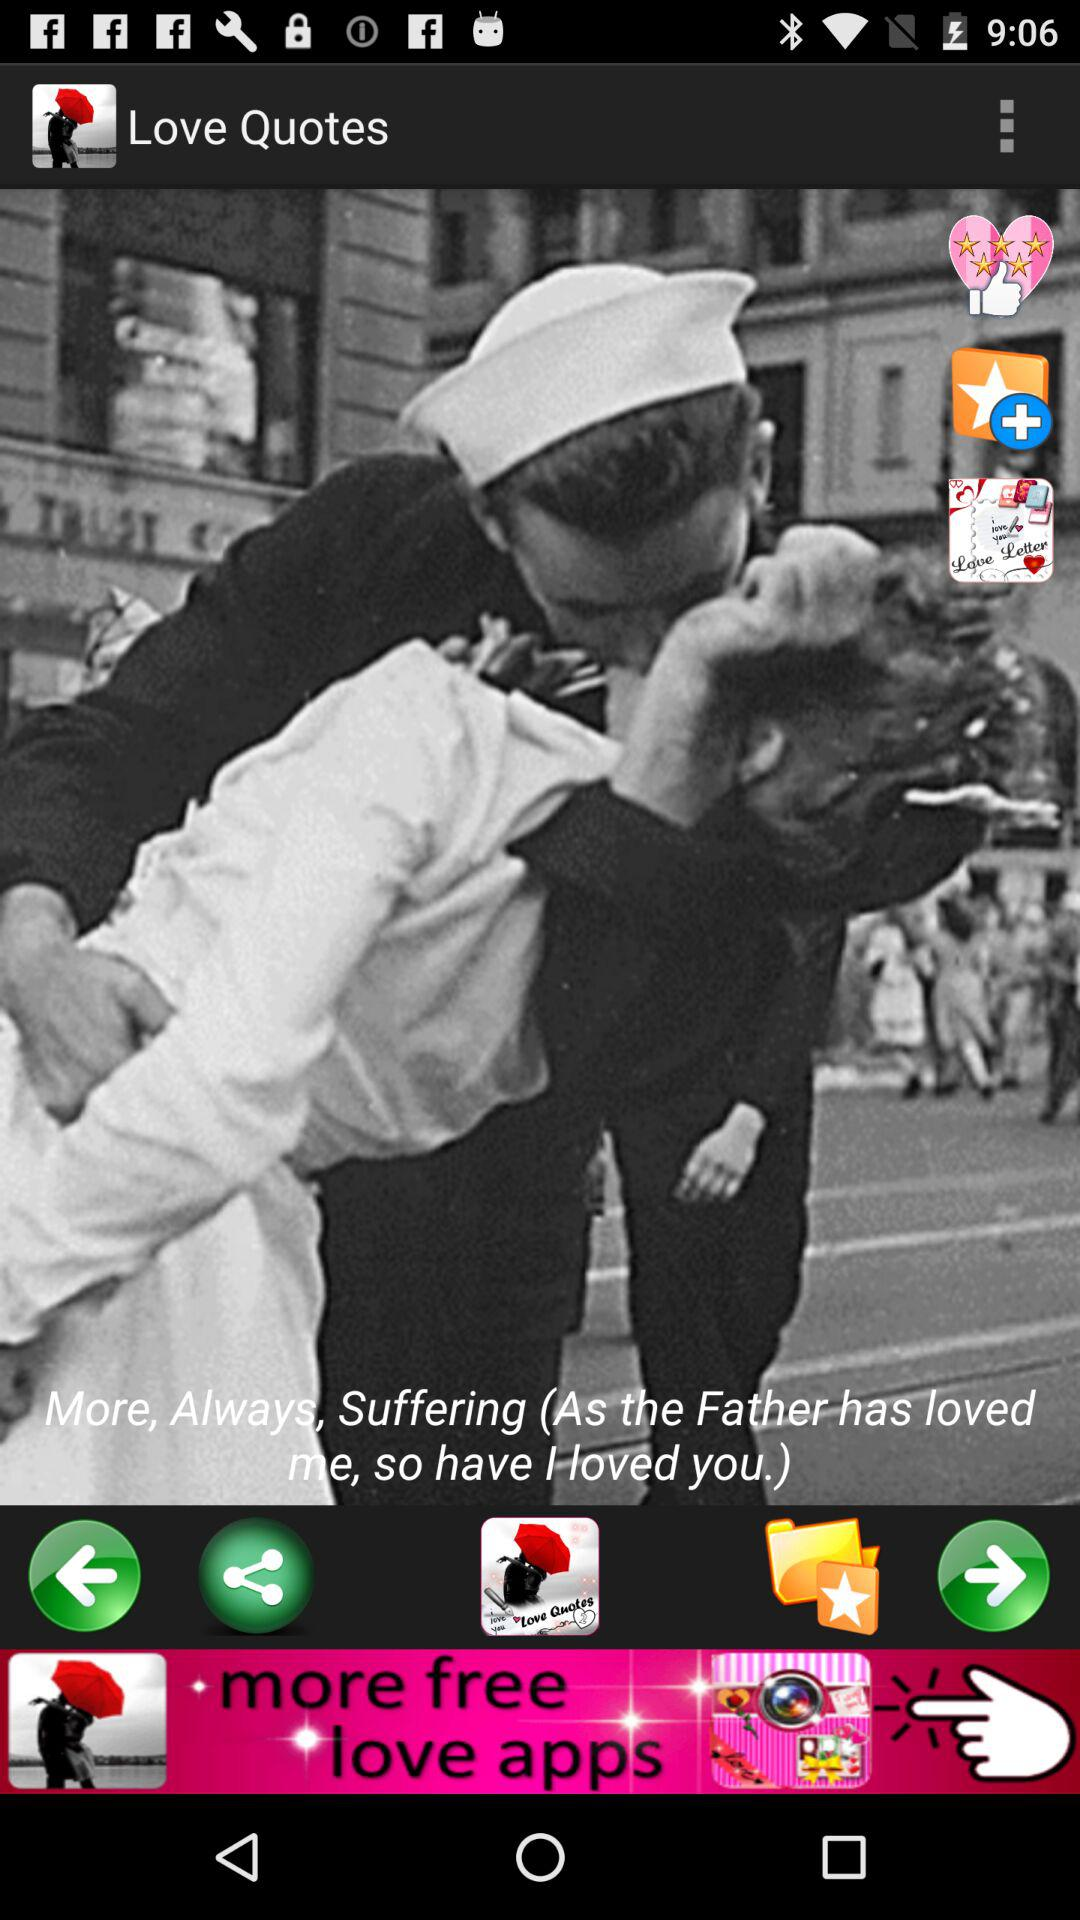What is the application name? The application name is "Love Quotes". 